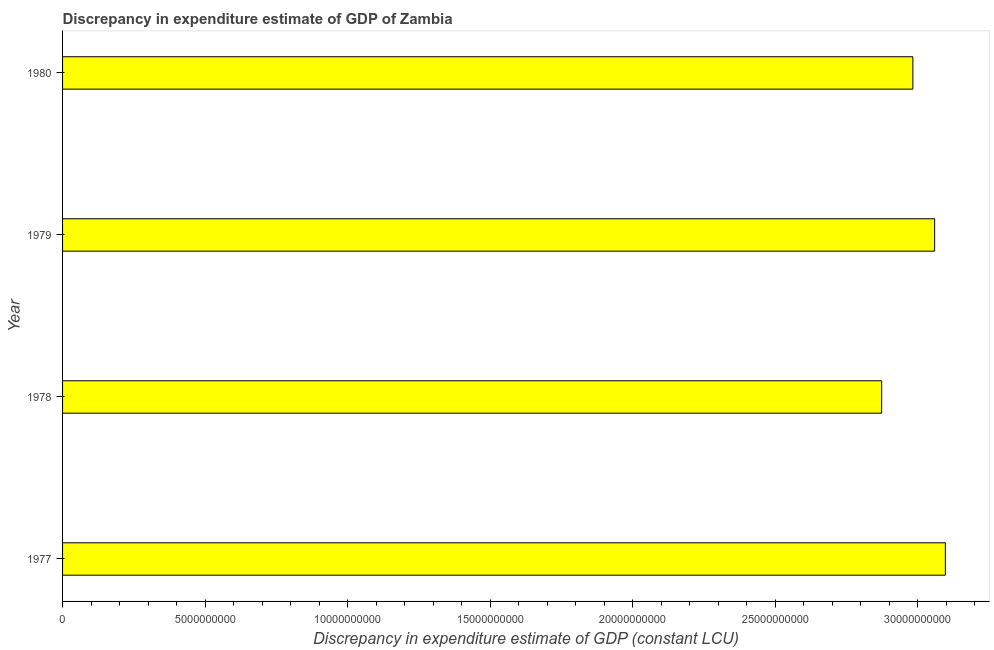Does the graph contain any zero values?
Provide a succinct answer. No. What is the title of the graph?
Offer a very short reply. Discrepancy in expenditure estimate of GDP of Zambia. What is the label or title of the X-axis?
Offer a very short reply. Discrepancy in expenditure estimate of GDP (constant LCU). What is the discrepancy in expenditure estimate of gdp in 1980?
Your answer should be very brief. 2.98e+1. Across all years, what is the maximum discrepancy in expenditure estimate of gdp?
Make the answer very short. 3.10e+1. Across all years, what is the minimum discrepancy in expenditure estimate of gdp?
Keep it short and to the point. 2.87e+1. In which year was the discrepancy in expenditure estimate of gdp minimum?
Your response must be concise. 1978. What is the sum of the discrepancy in expenditure estimate of gdp?
Offer a terse response. 1.20e+11. What is the difference between the discrepancy in expenditure estimate of gdp in 1978 and 1980?
Give a very brief answer. -1.09e+09. What is the average discrepancy in expenditure estimate of gdp per year?
Keep it short and to the point. 3.00e+1. What is the median discrepancy in expenditure estimate of gdp?
Your response must be concise. 3.02e+1. In how many years, is the discrepancy in expenditure estimate of gdp greater than 29000000000 LCU?
Give a very brief answer. 3. Is the discrepancy in expenditure estimate of gdp in 1977 less than that in 1978?
Ensure brevity in your answer.  No. Is the difference between the discrepancy in expenditure estimate of gdp in 1977 and 1980 greater than the difference between any two years?
Ensure brevity in your answer.  No. What is the difference between the highest and the second highest discrepancy in expenditure estimate of gdp?
Provide a short and direct response. 3.76e+08. Is the sum of the discrepancy in expenditure estimate of gdp in 1978 and 1980 greater than the maximum discrepancy in expenditure estimate of gdp across all years?
Provide a succinct answer. Yes. What is the difference between the highest and the lowest discrepancy in expenditure estimate of gdp?
Your answer should be compact. 2.23e+09. Are all the bars in the graph horizontal?
Provide a succinct answer. Yes. What is the difference between two consecutive major ticks on the X-axis?
Your response must be concise. 5.00e+09. Are the values on the major ticks of X-axis written in scientific E-notation?
Provide a short and direct response. No. What is the Discrepancy in expenditure estimate of GDP (constant LCU) of 1977?
Your response must be concise. 3.10e+1. What is the Discrepancy in expenditure estimate of GDP (constant LCU) of 1978?
Keep it short and to the point. 2.87e+1. What is the Discrepancy in expenditure estimate of GDP (constant LCU) in 1979?
Keep it short and to the point. 3.06e+1. What is the Discrepancy in expenditure estimate of GDP (constant LCU) of 1980?
Make the answer very short. 2.98e+1. What is the difference between the Discrepancy in expenditure estimate of GDP (constant LCU) in 1977 and 1978?
Your answer should be very brief. 2.23e+09. What is the difference between the Discrepancy in expenditure estimate of GDP (constant LCU) in 1977 and 1979?
Offer a terse response. 3.76e+08. What is the difference between the Discrepancy in expenditure estimate of GDP (constant LCU) in 1977 and 1980?
Keep it short and to the point. 1.14e+09. What is the difference between the Discrepancy in expenditure estimate of GDP (constant LCU) in 1978 and 1979?
Your answer should be very brief. -1.86e+09. What is the difference between the Discrepancy in expenditure estimate of GDP (constant LCU) in 1978 and 1980?
Your response must be concise. -1.09e+09. What is the difference between the Discrepancy in expenditure estimate of GDP (constant LCU) in 1979 and 1980?
Provide a succinct answer. 7.64e+08. What is the ratio of the Discrepancy in expenditure estimate of GDP (constant LCU) in 1977 to that in 1978?
Make the answer very short. 1.08. What is the ratio of the Discrepancy in expenditure estimate of GDP (constant LCU) in 1977 to that in 1980?
Your response must be concise. 1.04. What is the ratio of the Discrepancy in expenditure estimate of GDP (constant LCU) in 1978 to that in 1979?
Keep it short and to the point. 0.94. What is the ratio of the Discrepancy in expenditure estimate of GDP (constant LCU) in 1978 to that in 1980?
Keep it short and to the point. 0.96. What is the ratio of the Discrepancy in expenditure estimate of GDP (constant LCU) in 1979 to that in 1980?
Your answer should be very brief. 1.03. 